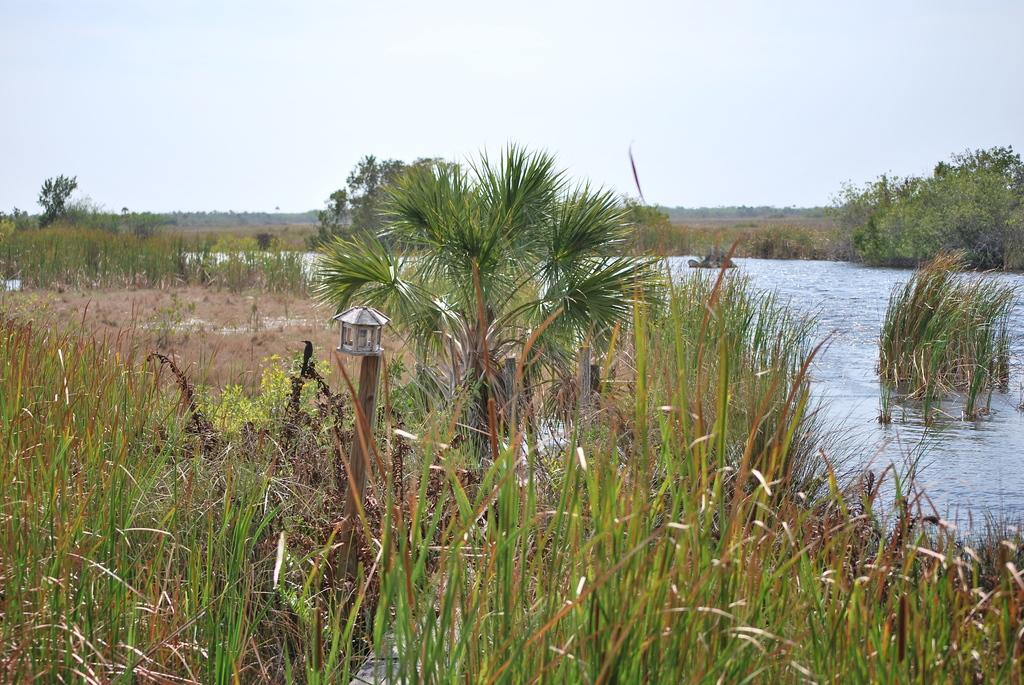What type of natural elements are present in the image? There are many trees and plants in the image. What can be seen on the pole in the image? There is something on the pole in the image, but the specifics are not mentioned in the facts. What body of water is visible in the image? There is water visible in the image, but the facts do not specify the type of water. What is visible in the background of the image? The sky is visible in the background of the image. What type of cheese is being used to flavor the water in the image? There is no cheese or flavoring mentioned in the image; it features trees, plants, a pole, water, and the sky. 